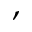<formula> <loc_0><loc_0><loc_500><loc_500>,</formula> 